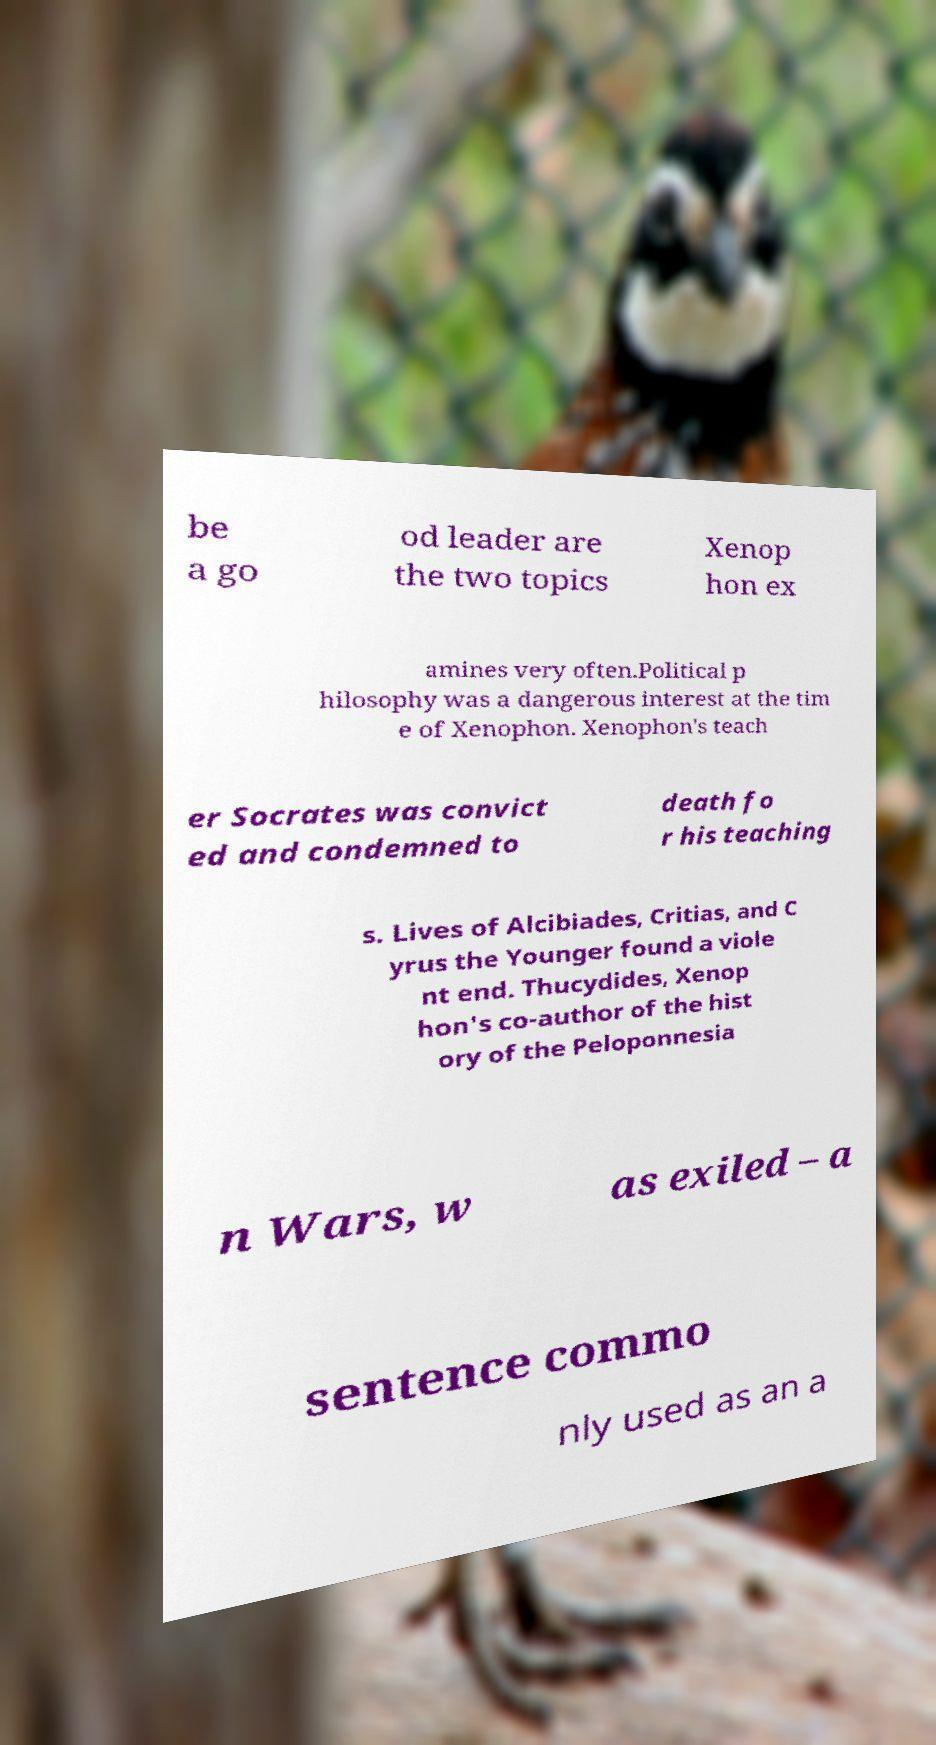I need the written content from this picture converted into text. Can you do that? be a go od leader are the two topics Xenop hon ex amines very often.Political p hilosophy was a dangerous interest at the tim e of Xenophon. Xenophon's teach er Socrates was convict ed and condemned to death fo r his teaching s. Lives of Alcibiades, Critias, and C yrus the Younger found a viole nt end. Thucydides, Xenop hon's co-author of the hist ory of the Peloponnesia n Wars, w as exiled – a sentence commo nly used as an a 